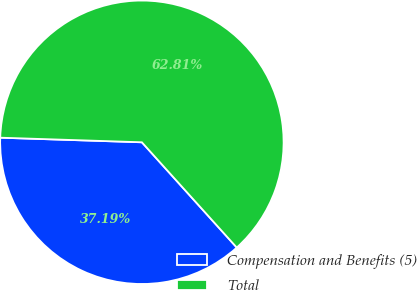Convert chart to OTSL. <chart><loc_0><loc_0><loc_500><loc_500><pie_chart><fcel>Compensation and Benefits (5)<fcel>Total<nl><fcel>37.19%<fcel>62.81%<nl></chart> 